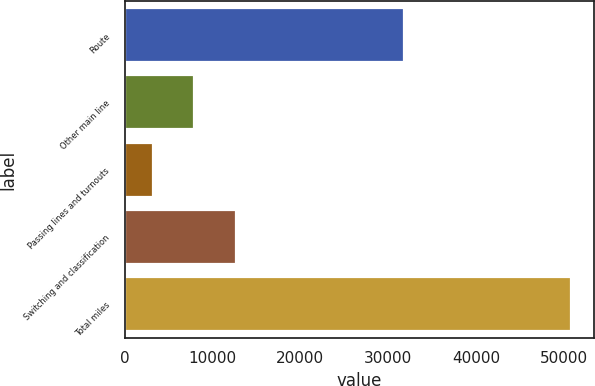Convert chart to OTSL. <chart><loc_0><loc_0><loc_500><loc_500><bar_chart><fcel>Route<fcel>Other main line<fcel>Passing lines and turnouts<fcel>Switching and classification<fcel>Total miles<nl><fcel>31838<fcel>7936.4<fcel>3167<fcel>12705.8<fcel>50861<nl></chart> 